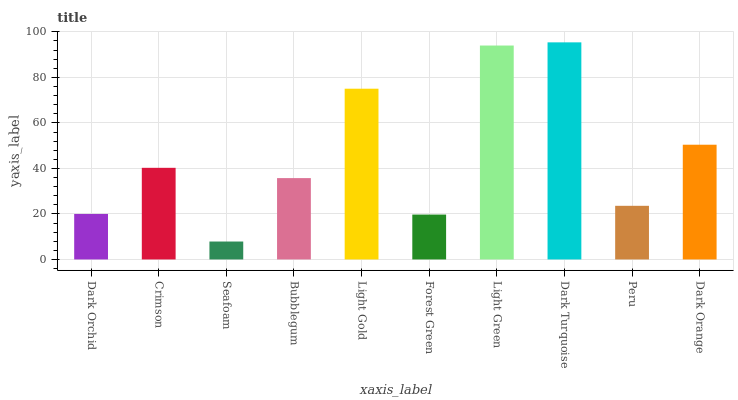Is Seafoam the minimum?
Answer yes or no. Yes. Is Dark Turquoise the maximum?
Answer yes or no. Yes. Is Crimson the minimum?
Answer yes or no. No. Is Crimson the maximum?
Answer yes or no. No. Is Crimson greater than Dark Orchid?
Answer yes or no. Yes. Is Dark Orchid less than Crimson?
Answer yes or no. Yes. Is Dark Orchid greater than Crimson?
Answer yes or no. No. Is Crimson less than Dark Orchid?
Answer yes or no. No. Is Crimson the high median?
Answer yes or no. Yes. Is Bubblegum the low median?
Answer yes or no. Yes. Is Dark Turquoise the high median?
Answer yes or no. No. Is Light Gold the low median?
Answer yes or no. No. 